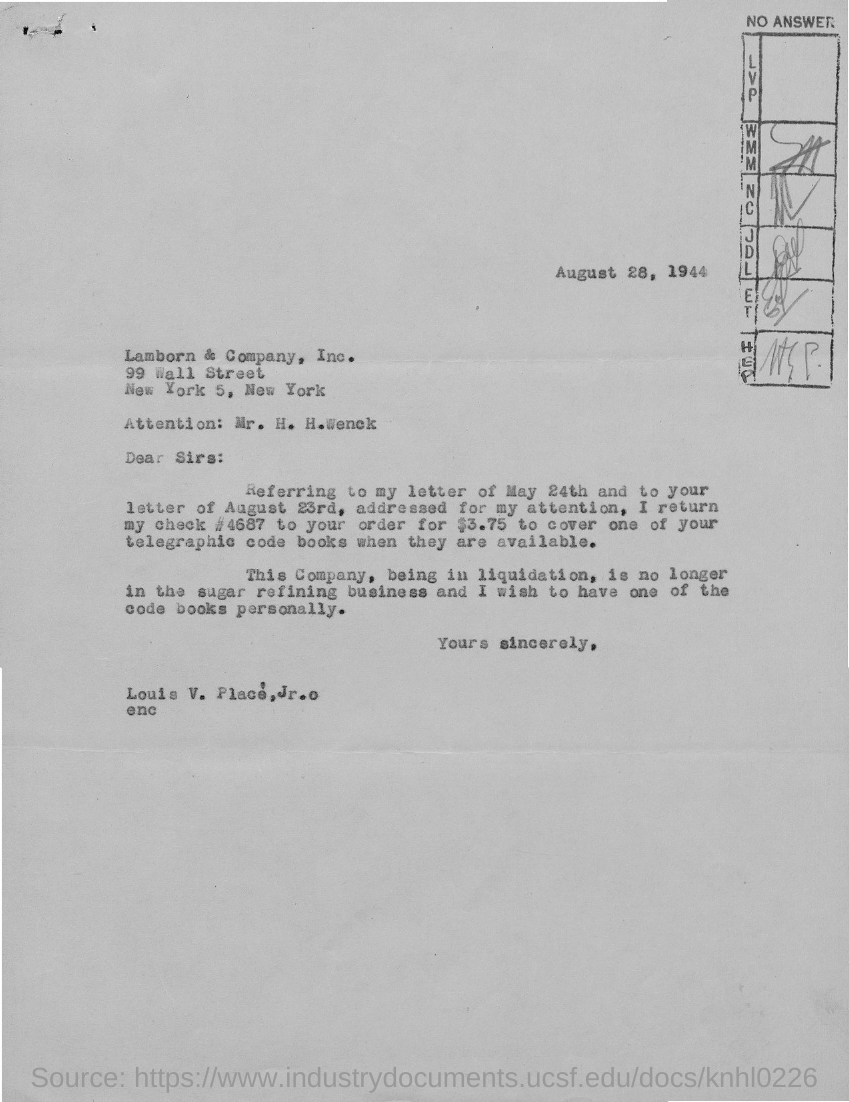Draw attention to some important aspects in this diagram. The sender of the letter is Louis V. Place, Jr. The letter is addressed to Lamborn & Company. The date on the letter is August 28, 1944. Louis V. Palace returns a check number of 4687. 